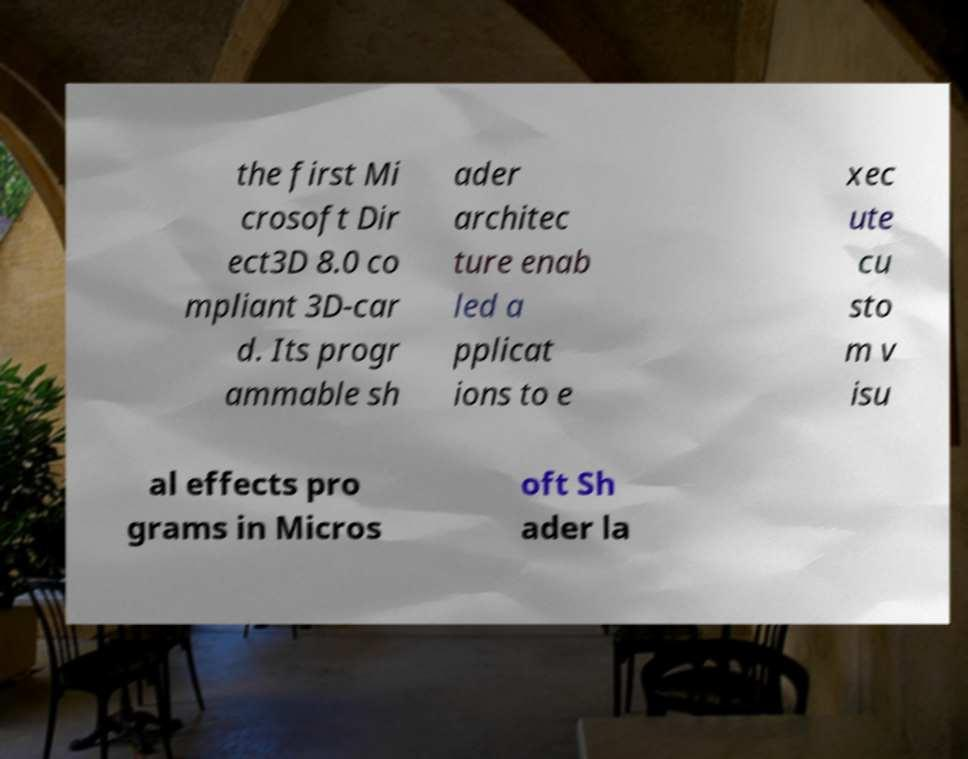Could you assist in decoding the text presented in this image and type it out clearly? the first Mi crosoft Dir ect3D 8.0 co mpliant 3D-car d. Its progr ammable sh ader architec ture enab led a pplicat ions to e xec ute cu sto m v isu al effects pro grams in Micros oft Sh ader la 